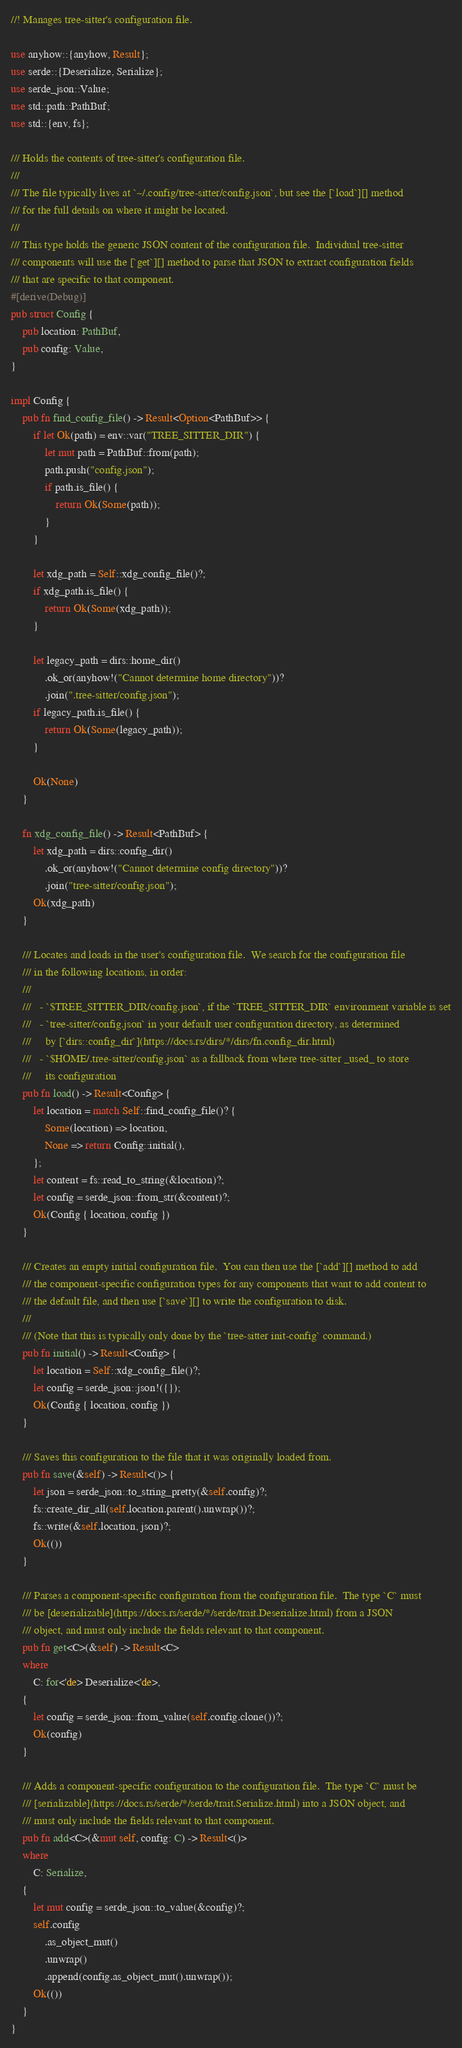Convert code to text. <code><loc_0><loc_0><loc_500><loc_500><_Rust_>//! Manages tree-sitter's configuration file.

use anyhow::{anyhow, Result};
use serde::{Deserialize, Serialize};
use serde_json::Value;
use std::path::PathBuf;
use std::{env, fs};

/// Holds the contents of tree-sitter's configuration file.
///
/// The file typically lives at `~/.config/tree-sitter/config.json`, but see the [`load`][] method
/// for the full details on where it might be located.
///
/// This type holds the generic JSON content of the configuration file.  Individual tree-sitter
/// components will use the [`get`][] method to parse that JSON to extract configuration fields
/// that are specific to that component.
#[derive(Debug)]
pub struct Config {
    pub location: PathBuf,
    pub config: Value,
}

impl Config {
    pub fn find_config_file() -> Result<Option<PathBuf>> {
        if let Ok(path) = env::var("TREE_SITTER_DIR") {
            let mut path = PathBuf::from(path);
            path.push("config.json");
            if path.is_file() {
                return Ok(Some(path));
            }
        }

        let xdg_path = Self::xdg_config_file()?;
        if xdg_path.is_file() {
            return Ok(Some(xdg_path));
        }

        let legacy_path = dirs::home_dir()
            .ok_or(anyhow!("Cannot determine home directory"))?
            .join(".tree-sitter/config.json");
        if legacy_path.is_file() {
            return Ok(Some(legacy_path));
        }

        Ok(None)
    }

    fn xdg_config_file() -> Result<PathBuf> {
        let xdg_path = dirs::config_dir()
            .ok_or(anyhow!("Cannot determine config directory"))?
            .join("tree-sitter/config.json");
        Ok(xdg_path)
    }

    /// Locates and loads in the user's configuration file.  We search for the configuration file
    /// in the following locations, in order:
    ///
    ///   - `$TREE_SITTER_DIR/config.json`, if the `TREE_SITTER_DIR` environment variable is set
    ///   - `tree-sitter/config.json` in your default user configuration directory, as determined
    ///     by [`dirs::config_dir`](https://docs.rs/dirs/*/dirs/fn.config_dir.html)
    ///   - `$HOME/.tree-sitter/config.json` as a fallback from where tree-sitter _used_ to store
    ///     its configuration
    pub fn load() -> Result<Config> {
        let location = match Self::find_config_file()? {
            Some(location) => location,
            None => return Config::initial(),
        };
        let content = fs::read_to_string(&location)?;
        let config = serde_json::from_str(&content)?;
        Ok(Config { location, config })
    }

    /// Creates an empty initial configuration file.  You can then use the [`add`][] method to add
    /// the component-specific configuration types for any components that want to add content to
    /// the default file, and then use [`save`][] to write the configuration to disk.
    ///
    /// (Note that this is typically only done by the `tree-sitter init-config` command.)
    pub fn initial() -> Result<Config> {
        let location = Self::xdg_config_file()?;
        let config = serde_json::json!({});
        Ok(Config { location, config })
    }

    /// Saves this configuration to the file that it was originally loaded from.
    pub fn save(&self) -> Result<()> {
        let json = serde_json::to_string_pretty(&self.config)?;
        fs::create_dir_all(self.location.parent().unwrap())?;
        fs::write(&self.location, json)?;
        Ok(())
    }

    /// Parses a component-specific configuration from the configuration file.  The type `C` must
    /// be [deserializable](https://docs.rs/serde/*/serde/trait.Deserialize.html) from a JSON
    /// object, and must only include the fields relevant to that component.
    pub fn get<C>(&self) -> Result<C>
    where
        C: for<'de> Deserialize<'de>,
    {
        let config = serde_json::from_value(self.config.clone())?;
        Ok(config)
    }

    /// Adds a component-specific configuration to the configuration file.  The type `C` must be
    /// [serializable](https://docs.rs/serde/*/serde/trait.Serialize.html) into a JSON object, and
    /// must only include the fields relevant to that component.
    pub fn add<C>(&mut self, config: C) -> Result<()>
    where
        C: Serialize,
    {
        let mut config = serde_json::to_value(&config)?;
        self.config
            .as_object_mut()
            .unwrap()
            .append(config.as_object_mut().unwrap());
        Ok(())
    }
}
</code> 